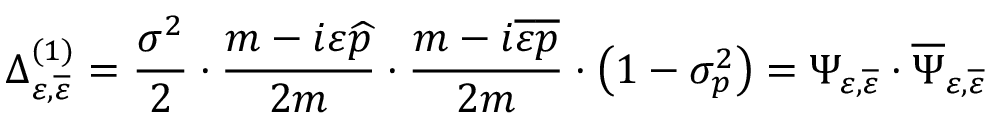<formula> <loc_0><loc_0><loc_500><loc_500>\Delta _ { \varepsilon , \overline { \varepsilon } } ^ { ( 1 ) } = \frac { \sigma ^ { 2 } } 2 \cdot \frac { m - i \varepsilon \widehat { p } } { 2 m } \cdot \frac { m - i \overline { \varepsilon } \overline { p } } { 2 m } \cdot \left ( 1 - \sigma _ { p } ^ { 2 } \right ) = \Psi _ { \varepsilon , \overline { \varepsilon } } \cdot \overline { \Psi } _ { \varepsilon , \overline { \varepsilon } }</formula> 